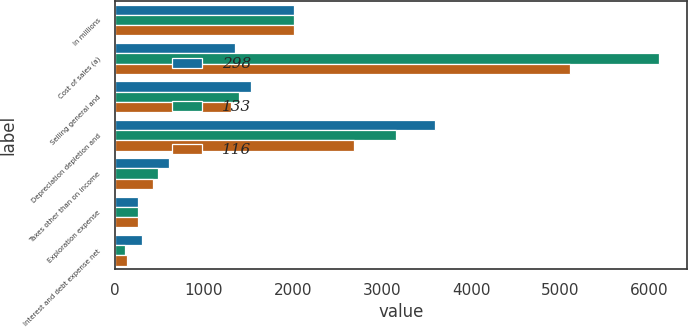Convert chart. <chart><loc_0><loc_0><loc_500><loc_500><stacked_bar_chart><ecel><fcel>In millions<fcel>Cost of sales (a)<fcel>Selling general and<fcel>Depreciation depletion and<fcel>Taxes other than on income<fcel>Exploration expense<fcel>Interest and debt expense net<nl><fcel>298<fcel>2011<fcel>1348<fcel>1523<fcel>3591<fcel>605<fcel>258<fcel>298<nl><fcel>133<fcel>2010<fcel>6112<fcel>1396<fcel>3153<fcel>484<fcel>262<fcel>116<nl><fcel>116<fcel>2009<fcel>5105<fcel>1300<fcel>2687<fcel>425<fcel>254<fcel>133<nl></chart> 